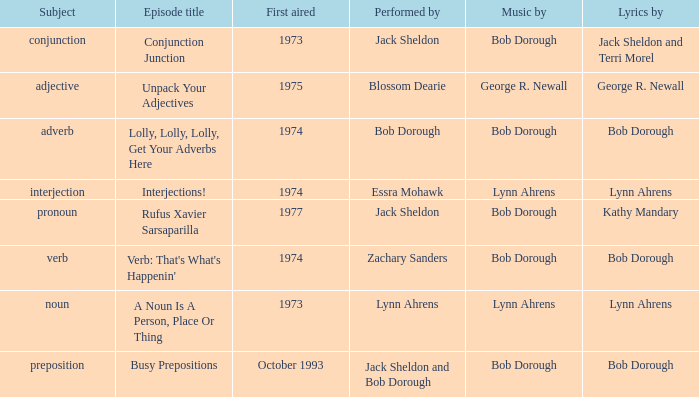Help me parse the entirety of this table. {'header': ['Subject', 'Episode title', 'First aired', 'Performed by', 'Music by', 'Lyrics by'], 'rows': [['conjunction', 'Conjunction Junction', '1973', 'Jack Sheldon', 'Bob Dorough', 'Jack Sheldon and Terri Morel'], ['adjective', 'Unpack Your Adjectives', '1975', 'Blossom Dearie', 'George R. Newall', 'George R. Newall'], ['adverb', 'Lolly, Lolly, Lolly, Get Your Adverbs Here', '1974', 'Bob Dorough', 'Bob Dorough', 'Bob Dorough'], ['interjection', 'Interjections!', '1974', 'Essra Mohawk', 'Lynn Ahrens', 'Lynn Ahrens'], ['pronoun', 'Rufus Xavier Sarsaparilla', '1977', 'Jack Sheldon', 'Bob Dorough', 'Kathy Mandary'], ['verb', "Verb: That's What's Happenin'", '1974', 'Zachary Sanders', 'Bob Dorough', 'Bob Dorough'], ['noun', 'A Noun Is A Person, Place Or Thing', '1973', 'Lynn Ahrens', 'Lynn Ahrens', 'Lynn Ahrens'], ['preposition', 'Busy Prepositions', 'October 1993', 'Jack Sheldon and Bob Dorough', 'Bob Dorough', 'Bob Dorough']]} When zachary sanders is the performer how many first aired are there? 1.0. 